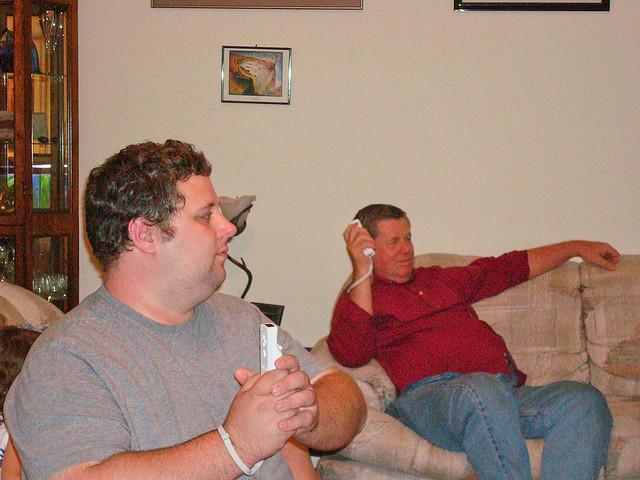What are the two men doing together? Please explain your reasoning. gaming. They are playing nintendo wii. 